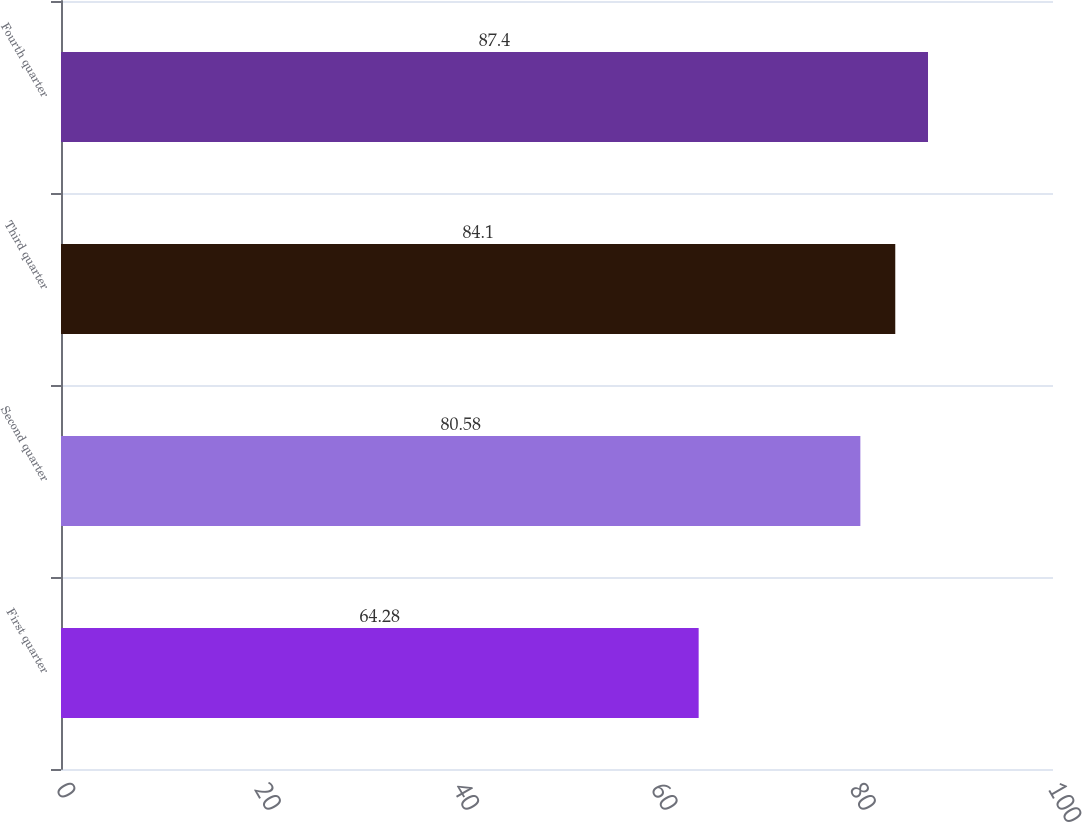Convert chart. <chart><loc_0><loc_0><loc_500><loc_500><bar_chart><fcel>First quarter<fcel>Second quarter<fcel>Third quarter<fcel>Fourth quarter<nl><fcel>64.28<fcel>80.58<fcel>84.1<fcel>87.4<nl></chart> 